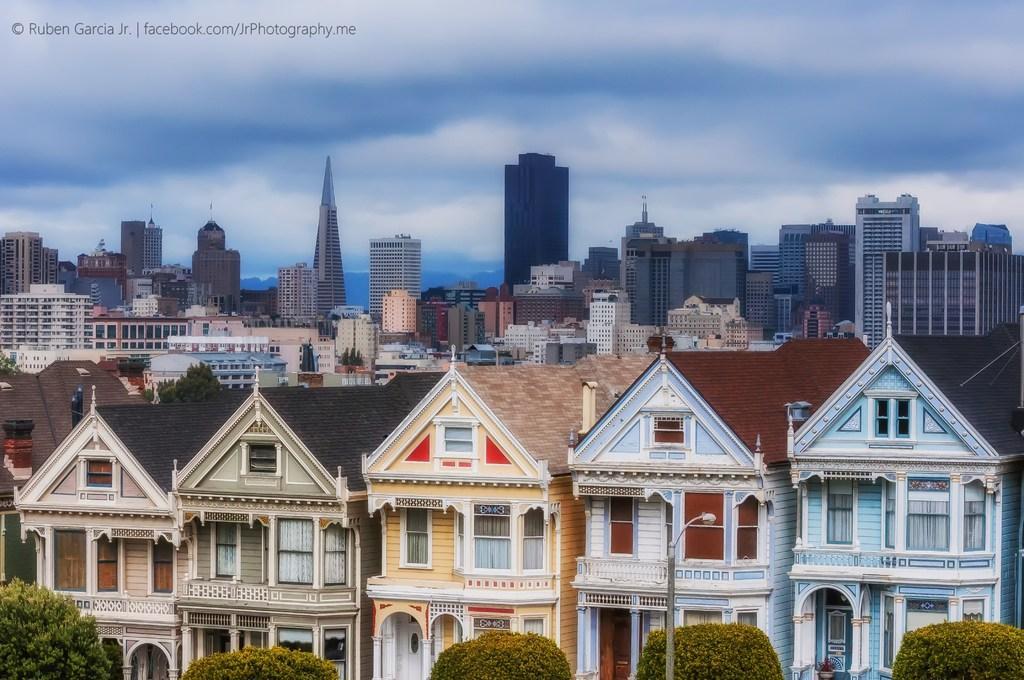Please provide a concise description of this image. In the foreground of the image we can see the street lights, same buildings with different colors and trees. In the middle of the image we can see trees. On the top of the image we can see the sky. 